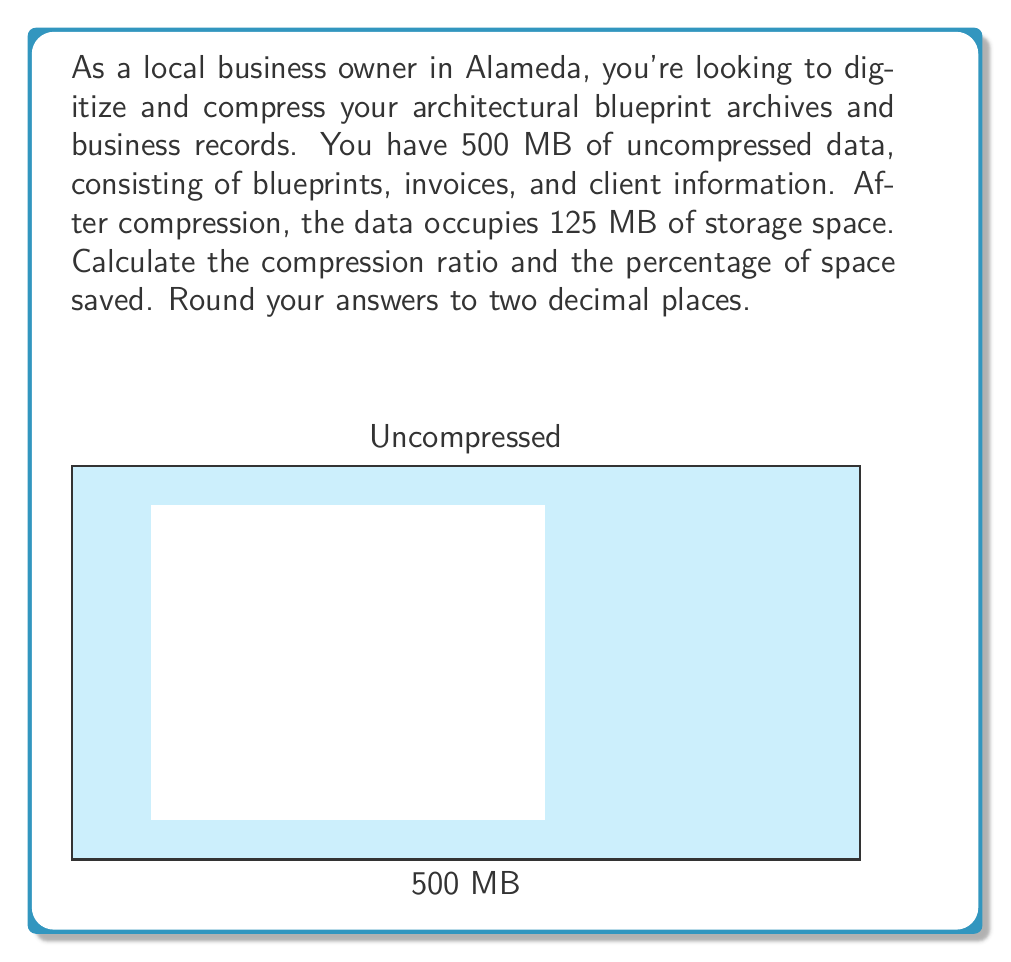Could you help me with this problem? Let's approach this step-by-step:

1) The compression ratio is defined as:

   $$ \text{Compression Ratio} = \frac{\text{Uncompressed Size}}{\text{Compressed Size}} $$

2) Substituting the given values:

   $$ \text{Compression Ratio} = \frac{500 \text{ MB}}{125 \text{ MB}} = 4 $$

3) To calculate the percentage of space saved, we first need to find the difference between the uncompressed and compressed sizes:

   $$ \text{Space Saved} = 500 \text{ MB} - 125 \text{ MB} = 375 \text{ MB} $$

4) Now, we can calculate the percentage of space saved:

   $$ \text{Percentage of Space Saved} = \frac{\text{Space Saved}}{\text{Uncompressed Size}} \times 100\% $$

   $$ = \frac{375 \text{ MB}}{500 \text{ MB}} \times 100\% = 0.75 \times 100\% = 75\% $$

5) Rounding both results to two decimal places:
   - Compression Ratio: 4.00
   - Percentage of Space Saved: 75.00%
Answer: Compression Ratio: 4.00, Space Saved: 75.00% 